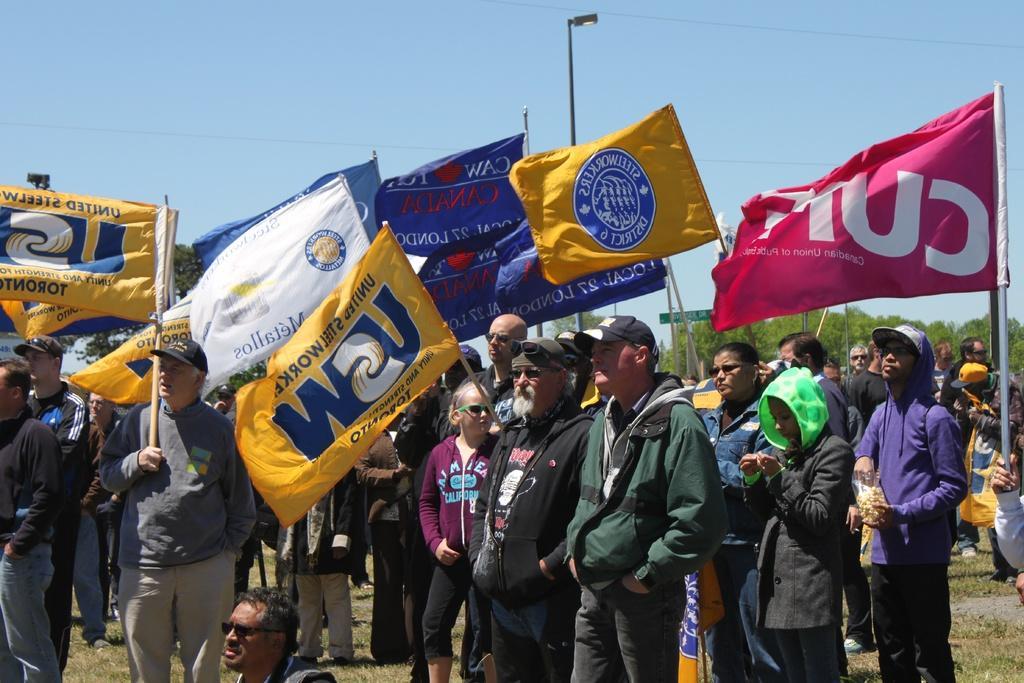Can you describe this image briefly? in the foreground of the picture there are people holding flags. In the background there are trees, streetlight, pole, cables and other objects. Sky is sunny. At the bottom there is grass. 